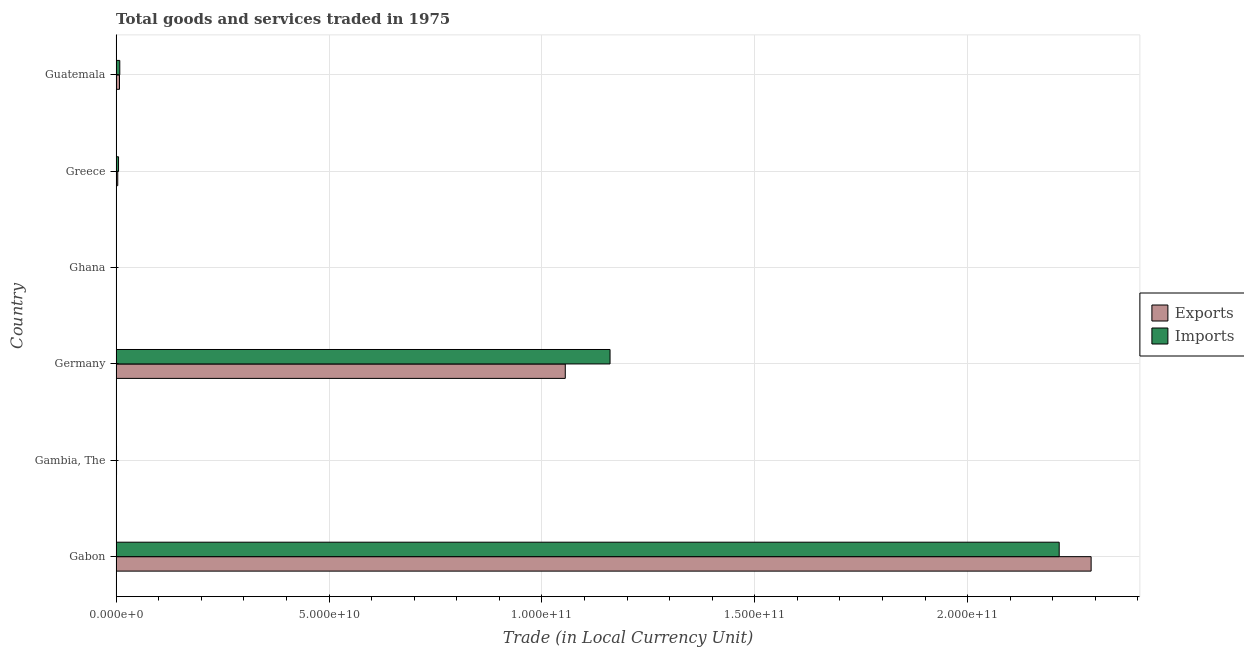Are the number of bars per tick equal to the number of legend labels?
Your response must be concise. Yes. Are the number of bars on each tick of the Y-axis equal?
Keep it short and to the point. Yes. What is the label of the 5th group of bars from the top?
Your response must be concise. Gambia, The. What is the imports of goods and services in Guatemala?
Your answer should be very brief. 8.58e+08. Across all countries, what is the maximum imports of goods and services?
Keep it short and to the point. 2.22e+11. Across all countries, what is the minimum export of goods and services?
Keep it short and to the point. 1.02e+05. In which country was the imports of goods and services maximum?
Ensure brevity in your answer.  Gabon. What is the total imports of goods and services in the graph?
Your response must be concise. 3.39e+11. What is the difference between the export of goods and services in Gambia, The and that in Germany?
Your answer should be compact. -1.05e+11. What is the difference between the export of goods and services in Gabon and the imports of goods and services in Greece?
Provide a short and direct response. 2.28e+11. What is the average imports of goods and services per country?
Ensure brevity in your answer.  5.65e+1. What is the difference between the export of goods and services and imports of goods and services in Ghana?
Provide a short and direct response. 4900. In how many countries, is the export of goods and services greater than 60000000000 LCU?
Provide a succinct answer. 2. What is the ratio of the export of goods and services in Gabon to that in Ghana?
Your answer should be very brief. 2.24e+06. What is the difference between the highest and the second highest imports of goods and services?
Give a very brief answer. 1.05e+11. What is the difference between the highest and the lowest export of goods and services?
Ensure brevity in your answer.  2.29e+11. In how many countries, is the export of goods and services greater than the average export of goods and services taken over all countries?
Offer a very short reply. 2. What does the 2nd bar from the top in Gabon represents?
Ensure brevity in your answer.  Exports. What does the 1st bar from the bottom in Greece represents?
Your answer should be very brief. Exports. How many bars are there?
Your answer should be very brief. 12. Are all the bars in the graph horizontal?
Make the answer very short. Yes. How many countries are there in the graph?
Your answer should be very brief. 6. What is the difference between two consecutive major ticks on the X-axis?
Keep it short and to the point. 5.00e+1. Are the values on the major ticks of X-axis written in scientific E-notation?
Your answer should be very brief. Yes. Does the graph contain any zero values?
Provide a short and direct response. No. Does the graph contain grids?
Your answer should be very brief. Yes. Where does the legend appear in the graph?
Keep it short and to the point. Center right. How are the legend labels stacked?
Ensure brevity in your answer.  Vertical. What is the title of the graph?
Provide a short and direct response. Total goods and services traded in 1975. Does "Frequency of shipment arrival" appear as one of the legend labels in the graph?
Offer a terse response. No. What is the label or title of the X-axis?
Your response must be concise. Trade (in Local Currency Unit). What is the label or title of the Y-axis?
Offer a terse response. Country. What is the Trade (in Local Currency Unit) in Exports in Gabon?
Ensure brevity in your answer.  2.29e+11. What is the Trade (in Local Currency Unit) of Imports in Gabon?
Your answer should be compact. 2.22e+11. What is the Trade (in Local Currency Unit) of Exports in Gambia, The?
Offer a very short reply. 9.31e+07. What is the Trade (in Local Currency Unit) in Imports in Gambia, The?
Offer a very short reply. 9.08e+07. What is the Trade (in Local Currency Unit) in Exports in Germany?
Keep it short and to the point. 1.05e+11. What is the Trade (in Local Currency Unit) of Imports in Germany?
Give a very brief answer. 1.16e+11. What is the Trade (in Local Currency Unit) of Exports in Ghana?
Ensure brevity in your answer.  1.02e+05. What is the Trade (in Local Currency Unit) of Imports in Ghana?
Provide a short and direct response. 9.74e+04. What is the Trade (in Local Currency Unit) of Exports in Greece?
Your answer should be compact. 3.80e+08. What is the Trade (in Local Currency Unit) of Imports in Greece?
Provide a short and direct response. 5.69e+08. What is the Trade (in Local Currency Unit) of Exports in Guatemala?
Your answer should be compact. 7.92e+08. What is the Trade (in Local Currency Unit) of Imports in Guatemala?
Offer a very short reply. 8.58e+08. Across all countries, what is the maximum Trade (in Local Currency Unit) in Exports?
Your answer should be very brief. 2.29e+11. Across all countries, what is the maximum Trade (in Local Currency Unit) of Imports?
Your response must be concise. 2.22e+11. Across all countries, what is the minimum Trade (in Local Currency Unit) of Exports?
Offer a very short reply. 1.02e+05. Across all countries, what is the minimum Trade (in Local Currency Unit) in Imports?
Offer a terse response. 9.74e+04. What is the total Trade (in Local Currency Unit) in Exports in the graph?
Make the answer very short. 3.36e+11. What is the total Trade (in Local Currency Unit) in Imports in the graph?
Ensure brevity in your answer.  3.39e+11. What is the difference between the Trade (in Local Currency Unit) in Exports in Gabon and that in Gambia, The?
Your answer should be very brief. 2.29e+11. What is the difference between the Trade (in Local Currency Unit) of Imports in Gabon and that in Gambia, The?
Your answer should be compact. 2.21e+11. What is the difference between the Trade (in Local Currency Unit) in Exports in Gabon and that in Germany?
Provide a succinct answer. 1.24e+11. What is the difference between the Trade (in Local Currency Unit) of Imports in Gabon and that in Germany?
Offer a terse response. 1.05e+11. What is the difference between the Trade (in Local Currency Unit) in Exports in Gabon and that in Ghana?
Provide a short and direct response. 2.29e+11. What is the difference between the Trade (in Local Currency Unit) in Imports in Gabon and that in Ghana?
Your response must be concise. 2.21e+11. What is the difference between the Trade (in Local Currency Unit) of Exports in Gabon and that in Greece?
Provide a short and direct response. 2.29e+11. What is the difference between the Trade (in Local Currency Unit) in Imports in Gabon and that in Greece?
Ensure brevity in your answer.  2.21e+11. What is the difference between the Trade (in Local Currency Unit) of Exports in Gabon and that in Guatemala?
Provide a succinct answer. 2.28e+11. What is the difference between the Trade (in Local Currency Unit) in Imports in Gabon and that in Guatemala?
Ensure brevity in your answer.  2.21e+11. What is the difference between the Trade (in Local Currency Unit) of Exports in Gambia, The and that in Germany?
Your response must be concise. -1.05e+11. What is the difference between the Trade (in Local Currency Unit) in Imports in Gambia, The and that in Germany?
Provide a short and direct response. -1.16e+11. What is the difference between the Trade (in Local Currency Unit) in Exports in Gambia, The and that in Ghana?
Provide a short and direct response. 9.30e+07. What is the difference between the Trade (in Local Currency Unit) in Imports in Gambia, The and that in Ghana?
Keep it short and to the point. 9.07e+07. What is the difference between the Trade (in Local Currency Unit) of Exports in Gambia, The and that in Greece?
Provide a short and direct response. -2.86e+08. What is the difference between the Trade (in Local Currency Unit) in Imports in Gambia, The and that in Greece?
Your answer should be compact. -4.78e+08. What is the difference between the Trade (in Local Currency Unit) of Exports in Gambia, The and that in Guatemala?
Provide a short and direct response. -6.99e+08. What is the difference between the Trade (in Local Currency Unit) in Imports in Gambia, The and that in Guatemala?
Your response must be concise. -7.67e+08. What is the difference between the Trade (in Local Currency Unit) in Exports in Germany and that in Ghana?
Keep it short and to the point. 1.05e+11. What is the difference between the Trade (in Local Currency Unit) in Imports in Germany and that in Ghana?
Give a very brief answer. 1.16e+11. What is the difference between the Trade (in Local Currency Unit) of Exports in Germany and that in Greece?
Your answer should be very brief. 1.05e+11. What is the difference between the Trade (in Local Currency Unit) of Imports in Germany and that in Greece?
Give a very brief answer. 1.15e+11. What is the difference between the Trade (in Local Currency Unit) of Exports in Germany and that in Guatemala?
Offer a terse response. 1.05e+11. What is the difference between the Trade (in Local Currency Unit) in Imports in Germany and that in Guatemala?
Provide a short and direct response. 1.15e+11. What is the difference between the Trade (in Local Currency Unit) of Exports in Ghana and that in Greece?
Offer a terse response. -3.80e+08. What is the difference between the Trade (in Local Currency Unit) of Imports in Ghana and that in Greece?
Keep it short and to the point. -5.68e+08. What is the difference between the Trade (in Local Currency Unit) of Exports in Ghana and that in Guatemala?
Your answer should be very brief. -7.92e+08. What is the difference between the Trade (in Local Currency Unit) of Imports in Ghana and that in Guatemala?
Your response must be concise. -8.58e+08. What is the difference between the Trade (in Local Currency Unit) in Exports in Greece and that in Guatemala?
Your answer should be compact. -4.12e+08. What is the difference between the Trade (in Local Currency Unit) of Imports in Greece and that in Guatemala?
Give a very brief answer. -2.89e+08. What is the difference between the Trade (in Local Currency Unit) in Exports in Gabon and the Trade (in Local Currency Unit) in Imports in Gambia, The?
Provide a short and direct response. 2.29e+11. What is the difference between the Trade (in Local Currency Unit) in Exports in Gabon and the Trade (in Local Currency Unit) in Imports in Germany?
Your answer should be very brief. 1.13e+11. What is the difference between the Trade (in Local Currency Unit) of Exports in Gabon and the Trade (in Local Currency Unit) of Imports in Ghana?
Give a very brief answer. 2.29e+11. What is the difference between the Trade (in Local Currency Unit) in Exports in Gabon and the Trade (in Local Currency Unit) in Imports in Greece?
Give a very brief answer. 2.28e+11. What is the difference between the Trade (in Local Currency Unit) in Exports in Gabon and the Trade (in Local Currency Unit) in Imports in Guatemala?
Give a very brief answer. 2.28e+11. What is the difference between the Trade (in Local Currency Unit) of Exports in Gambia, The and the Trade (in Local Currency Unit) of Imports in Germany?
Your response must be concise. -1.16e+11. What is the difference between the Trade (in Local Currency Unit) in Exports in Gambia, The and the Trade (in Local Currency Unit) in Imports in Ghana?
Your answer should be very brief. 9.30e+07. What is the difference between the Trade (in Local Currency Unit) in Exports in Gambia, The and the Trade (in Local Currency Unit) in Imports in Greece?
Offer a very short reply. -4.75e+08. What is the difference between the Trade (in Local Currency Unit) in Exports in Gambia, The and the Trade (in Local Currency Unit) in Imports in Guatemala?
Keep it short and to the point. -7.65e+08. What is the difference between the Trade (in Local Currency Unit) in Exports in Germany and the Trade (in Local Currency Unit) in Imports in Ghana?
Offer a terse response. 1.05e+11. What is the difference between the Trade (in Local Currency Unit) in Exports in Germany and the Trade (in Local Currency Unit) in Imports in Greece?
Your answer should be compact. 1.05e+11. What is the difference between the Trade (in Local Currency Unit) in Exports in Germany and the Trade (in Local Currency Unit) in Imports in Guatemala?
Give a very brief answer. 1.05e+11. What is the difference between the Trade (in Local Currency Unit) of Exports in Ghana and the Trade (in Local Currency Unit) of Imports in Greece?
Provide a short and direct response. -5.68e+08. What is the difference between the Trade (in Local Currency Unit) of Exports in Ghana and the Trade (in Local Currency Unit) of Imports in Guatemala?
Provide a succinct answer. -8.58e+08. What is the difference between the Trade (in Local Currency Unit) of Exports in Greece and the Trade (in Local Currency Unit) of Imports in Guatemala?
Your answer should be very brief. -4.78e+08. What is the average Trade (in Local Currency Unit) in Exports per country?
Your response must be concise. 5.60e+1. What is the average Trade (in Local Currency Unit) of Imports per country?
Give a very brief answer. 5.65e+1. What is the difference between the Trade (in Local Currency Unit) in Exports and Trade (in Local Currency Unit) in Imports in Gabon?
Provide a short and direct response. 7.50e+09. What is the difference between the Trade (in Local Currency Unit) of Exports and Trade (in Local Currency Unit) of Imports in Gambia, The?
Give a very brief answer. 2.28e+06. What is the difference between the Trade (in Local Currency Unit) of Exports and Trade (in Local Currency Unit) of Imports in Germany?
Provide a succinct answer. -1.05e+1. What is the difference between the Trade (in Local Currency Unit) in Exports and Trade (in Local Currency Unit) in Imports in Ghana?
Ensure brevity in your answer.  4900. What is the difference between the Trade (in Local Currency Unit) in Exports and Trade (in Local Currency Unit) in Imports in Greece?
Your answer should be very brief. -1.89e+08. What is the difference between the Trade (in Local Currency Unit) of Exports and Trade (in Local Currency Unit) of Imports in Guatemala?
Your response must be concise. -6.60e+07. What is the ratio of the Trade (in Local Currency Unit) in Exports in Gabon to that in Gambia, The?
Make the answer very short. 2459.57. What is the ratio of the Trade (in Local Currency Unit) in Imports in Gabon to that in Gambia, The?
Ensure brevity in your answer.  2438.69. What is the ratio of the Trade (in Local Currency Unit) in Exports in Gabon to that in Germany?
Offer a terse response. 2.17. What is the ratio of the Trade (in Local Currency Unit) of Imports in Gabon to that in Germany?
Offer a terse response. 1.91. What is the ratio of the Trade (in Local Currency Unit) in Exports in Gabon to that in Ghana?
Ensure brevity in your answer.  2.24e+06. What is the ratio of the Trade (in Local Currency Unit) of Imports in Gabon to that in Ghana?
Give a very brief answer. 2.27e+06. What is the ratio of the Trade (in Local Currency Unit) in Exports in Gabon to that in Greece?
Offer a very short reply. 603.26. What is the ratio of the Trade (in Local Currency Unit) of Imports in Gabon to that in Greece?
Provide a short and direct response. 389.58. What is the ratio of the Trade (in Local Currency Unit) in Exports in Gabon to that in Guatemala?
Make the answer very short. 289.14. What is the ratio of the Trade (in Local Currency Unit) in Imports in Gabon to that in Guatemala?
Your response must be concise. 258.16. What is the ratio of the Trade (in Local Currency Unit) in Exports in Gambia, The to that in Germany?
Ensure brevity in your answer.  0. What is the ratio of the Trade (in Local Currency Unit) of Imports in Gambia, The to that in Germany?
Your answer should be compact. 0. What is the ratio of the Trade (in Local Currency Unit) in Exports in Gambia, The to that in Ghana?
Your answer should be compact. 910.12. What is the ratio of the Trade (in Local Currency Unit) of Imports in Gambia, The to that in Ghana?
Keep it short and to the point. 932.52. What is the ratio of the Trade (in Local Currency Unit) in Exports in Gambia, The to that in Greece?
Your response must be concise. 0.25. What is the ratio of the Trade (in Local Currency Unit) of Imports in Gambia, The to that in Greece?
Give a very brief answer. 0.16. What is the ratio of the Trade (in Local Currency Unit) of Exports in Gambia, The to that in Guatemala?
Offer a very short reply. 0.12. What is the ratio of the Trade (in Local Currency Unit) in Imports in Gambia, The to that in Guatemala?
Ensure brevity in your answer.  0.11. What is the ratio of the Trade (in Local Currency Unit) of Exports in Germany to that in Ghana?
Provide a short and direct response. 1.03e+06. What is the ratio of the Trade (in Local Currency Unit) of Imports in Germany to that in Ghana?
Provide a succinct answer. 1.19e+06. What is the ratio of the Trade (in Local Currency Unit) of Exports in Germany to that in Greece?
Your response must be concise. 277.9. What is the ratio of the Trade (in Local Currency Unit) of Imports in Germany to that in Greece?
Make the answer very short. 204.03. What is the ratio of the Trade (in Local Currency Unit) in Exports in Germany to that in Guatemala?
Ensure brevity in your answer.  133.2. What is the ratio of the Trade (in Local Currency Unit) in Imports in Germany to that in Guatemala?
Offer a terse response. 135.21. What is the ratio of the Trade (in Local Currency Unit) of Exports in Ghana to that in Guatemala?
Provide a succinct answer. 0. What is the ratio of the Trade (in Local Currency Unit) in Exports in Greece to that in Guatemala?
Give a very brief answer. 0.48. What is the ratio of the Trade (in Local Currency Unit) in Imports in Greece to that in Guatemala?
Your response must be concise. 0.66. What is the difference between the highest and the second highest Trade (in Local Currency Unit) of Exports?
Your answer should be compact. 1.24e+11. What is the difference between the highest and the second highest Trade (in Local Currency Unit) of Imports?
Provide a succinct answer. 1.05e+11. What is the difference between the highest and the lowest Trade (in Local Currency Unit) in Exports?
Offer a very short reply. 2.29e+11. What is the difference between the highest and the lowest Trade (in Local Currency Unit) in Imports?
Provide a succinct answer. 2.21e+11. 